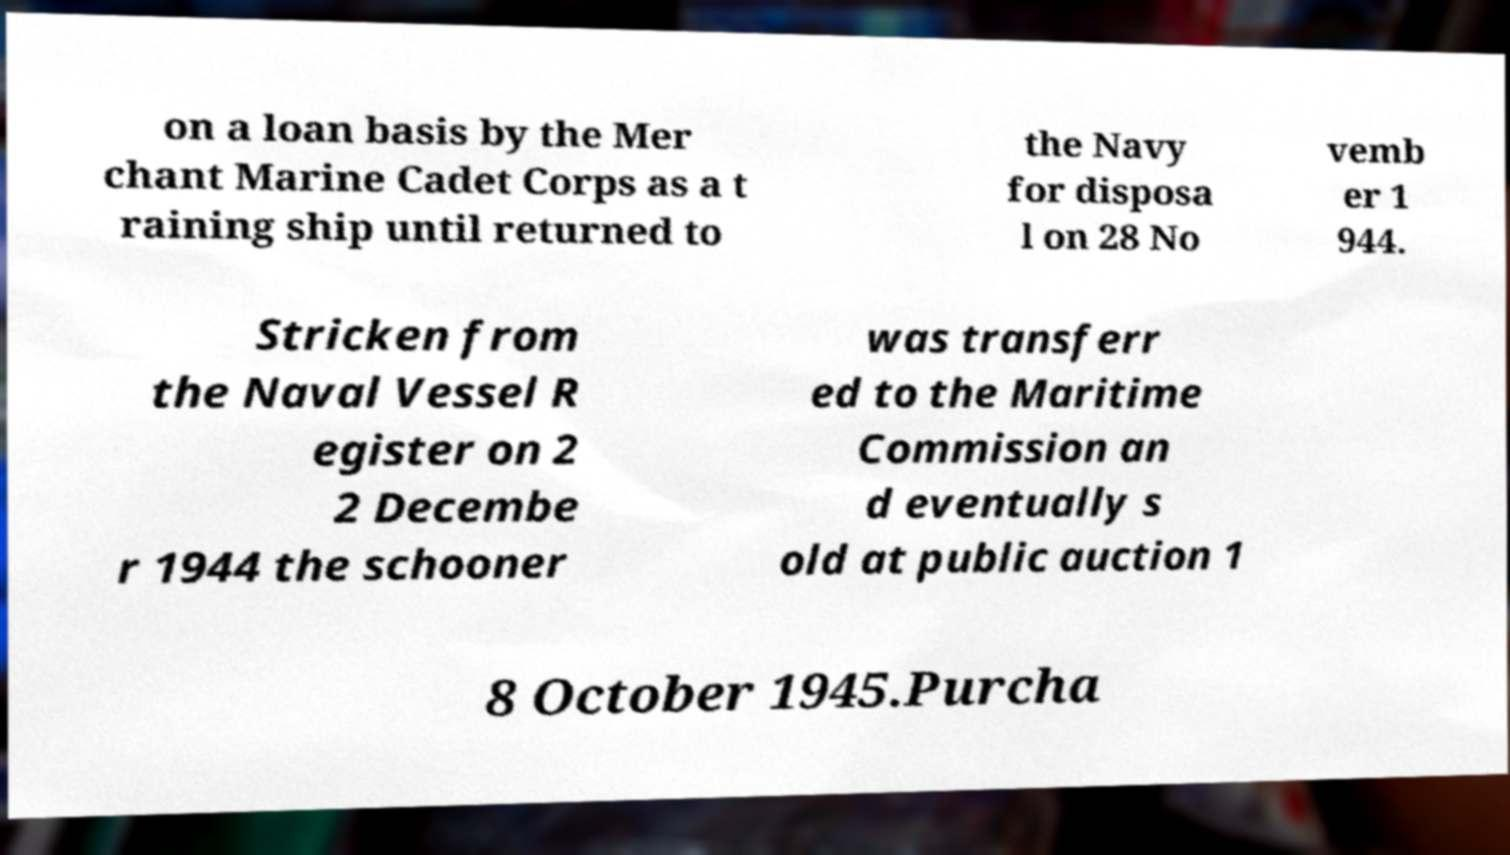Please identify and transcribe the text found in this image. on a loan basis by the Mer chant Marine Cadet Corps as a t raining ship until returned to the Navy for disposa l on 28 No vemb er 1 944. Stricken from the Naval Vessel R egister on 2 2 Decembe r 1944 the schooner was transferr ed to the Maritime Commission an d eventually s old at public auction 1 8 October 1945.Purcha 